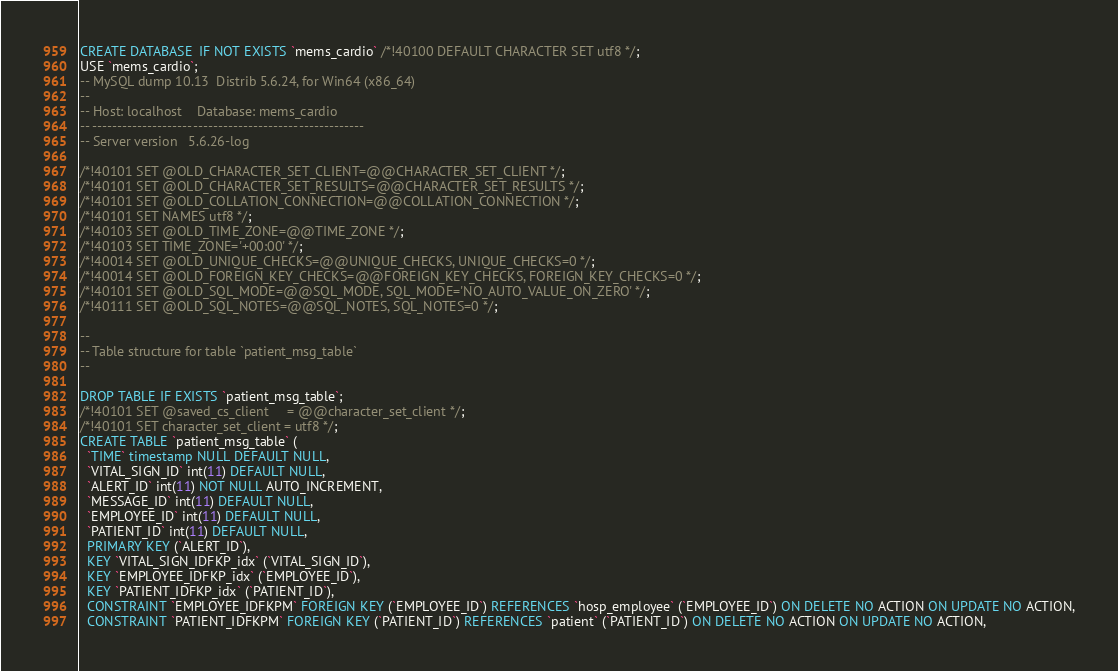Convert code to text. <code><loc_0><loc_0><loc_500><loc_500><_SQL_>CREATE DATABASE  IF NOT EXISTS `mems_cardio` /*!40100 DEFAULT CHARACTER SET utf8 */;
USE `mems_cardio`;
-- MySQL dump 10.13  Distrib 5.6.24, for Win64 (x86_64)
--
-- Host: localhost    Database: mems_cardio
-- ------------------------------------------------------
-- Server version	5.6.26-log

/*!40101 SET @OLD_CHARACTER_SET_CLIENT=@@CHARACTER_SET_CLIENT */;
/*!40101 SET @OLD_CHARACTER_SET_RESULTS=@@CHARACTER_SET_RESULTS */;
/*!40101 SET @OLD_COLLATION_CONNECTION=@@COLLATION_CONNECTION */;
/*!40101 SET NAMES utf8 */;
/*!40103 SET @OLD_TIME_ZONE=@@TIME_ZONE */;
/*!40103 SET TIME_ZONE='+00:00' */;
/*!40014 SET @OLD_UNIQUE_CHECKS=@@UNIQUE_CHECKS, UNIQUE_CHECKS=0 */;
/*!40014 SET @OLD_FOREIGN_KEY_CHECKS=@@FOREIGN_KEY_CHECKS, FOREIGN_KEY_CHECKS=0 */;
/*!40101 SET @OLD_SQL_MODE=@@SQL_MODE, SQL_MODE='NO_AUTO_VALUE_ON_ZERO' */;
/*!40111 SET @OLD_SQL_NOTES=@@SQL_NOTES, SQL_NOTES=0 */;

--
-- Table structure for table `patient_msg_table`
--

DROP TABLE IF EXISTS `patient_msg_table`;
/*!40101 SET @saved_cs_client     = @@character_set_client */;
/*!40101 SET character_set_client = utf8 */;
CREATE TABLE `patient_msg_table` (
  `TIME` timestamp NULL DEFAULT NULL,
  `VITAL_SIGN_ID` int(11) DEFAULT NULL,
  `ALERT_ID` int(11) NOT NULL AUTO_INCREMENT,
  `MESSAGE_ID` int(11) DEFAULT NULL,
  `EMPLOYEE_ID` int(11) DEFAULT NULL,
  `PATIENT_ID` int(11) DEFAULT NULL,
  PRIMARY KEY (`ALERT_ID`),
  KEY `VITAL_SIGN_IDFKP_idx` (`VITAL_SIGN_ID`),
  KEY `EMPLOYEE_IDFKP_idx` (`EMPLOYEE_ID`),
  KEY `PATIENT_IDFKP_idx` (`PATIENT_ID`),
  CONSTRAINT `EMPLOYEE_IDFKPM` FOREIGN KEY (`EMPLOYEE_ID`) REFERENCES `hosp_employee` (`EMPLOYEE_ID`) ON DELETE NO ACTION ON UPDATE NO ACTION,
  CONSTRAINT `PATIENT_IDFKPM` FOREIGN KEY (`PATIENT_ID`) REFERENCES `patient` (`PATIENT_ID`) ON DELETE NO ACTION ON UPDATE NO ACTION,</code> 